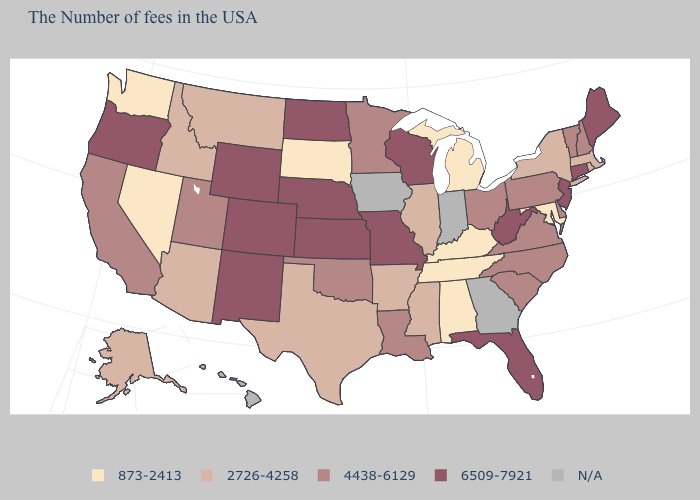What is the value of West Virginia?
Give a very brief answer. 6509-7921. Among the states that border Missouri , which have the lowest value?
Quick response, please. Kentucky, Tennessee. What is the value of Massachusetts?
Give a very brief answer. 2726-4258. What is the value of Indiana?
Give a very brief answer. N/A. What is the value of Massachusetts?
Answer briefly. 2726-4258. What is the value of Indiana?
Write a very short answer. N/A. Name the states that have a value in the range 4438-6129?
Keep it brief. New Hampshire, Vermont, Delaware, Pennsylvania, Virginia, North Carolina, South Carolina, Ohio, Louisiana, Minnesota, Oklahoma, Utah, California. Does the first symbol in the legend represent the smallest category?
Short answer required. Yes. How many symbols are there in the legend?
Keep it brief. 5. What is the value of Wisconsin?
Give a very brief answer. 6509-7921. Among the states that border Massachusetts , which have the lowest value?
Quick response, please. Rhode Island, New York. Among the states that border Nevada , does Arizona have the lowest value?
Be succinct. Yes. Does the first symbol in the legend represent the smallest category?
Quick response, please. Yes. Name the states that have a value in the range 6509-7921?
Concise answer only. Maine, Connecticut, New Jersey, West Virginia, Florida, Wisconsin, Missouri, Kansas, Nebraska, North Dakota, Wyoming, Colorado, New Mexico, Oregon. 